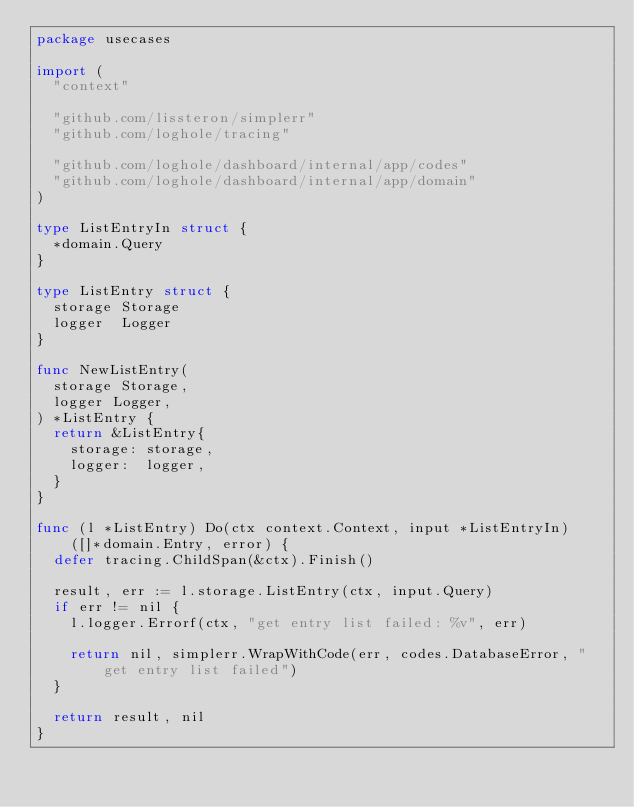<code> <loc_0><loc_0><loc_500><loc_500><_Go_>package usecases

import (
	"context"

	"github.com/lissteron/simplerr"
	"github.com/loghole/tracing"

	"github.com/loghole/dashboard/internal/app/codes"
	"github.com/loghole/dashboard/internal/app/domain"
)

type ListEntryIn struct {
	*domain.Query
}

type ListEntry struct {
	storage Storage
	logger  Logger
}

func NewListEntry(
	storage Storage,
	logger Logger,
) *ListEntry {
	return &ListEntry{
		storage: storage,
		logger:  logger,
	}
}

func (l *ListEntry) Do(ctx context.Context, input *ListEntryIn) ([]*domain.Entry, error) {
	defer tracing.ChildSpan(&ctx).Finish()

	result, err := l.storage.ListEntry(ctx, input.Query)
	if err != nil {
		l.logger.Errorf(ctx, "get entry list failed: %v", err)

		return nil, simplerr.WrapWithCode(err, codes.DatabaseError, "get entry list failed")
	}

	return result, nil
}
</code> 